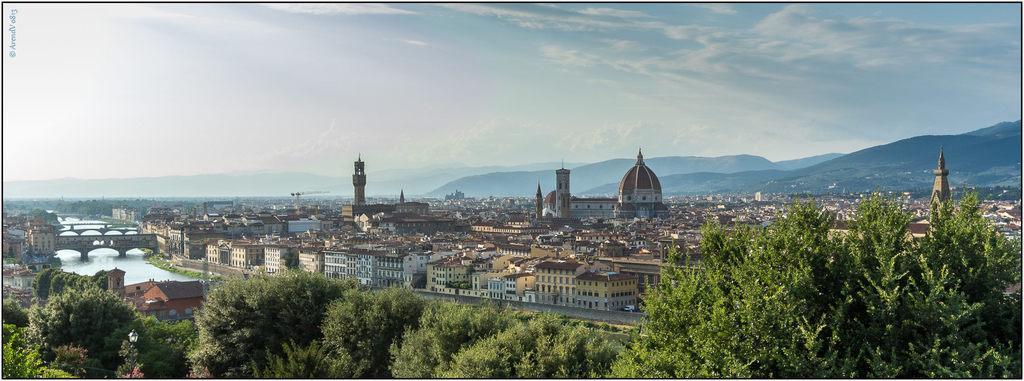How would you summarize this image in a sentence or two? In this image we can see some buildings and trees and we can see the water and few bridges over the water on the left side of the image. We can see the mountains in the background and at the top we can see the sky. 